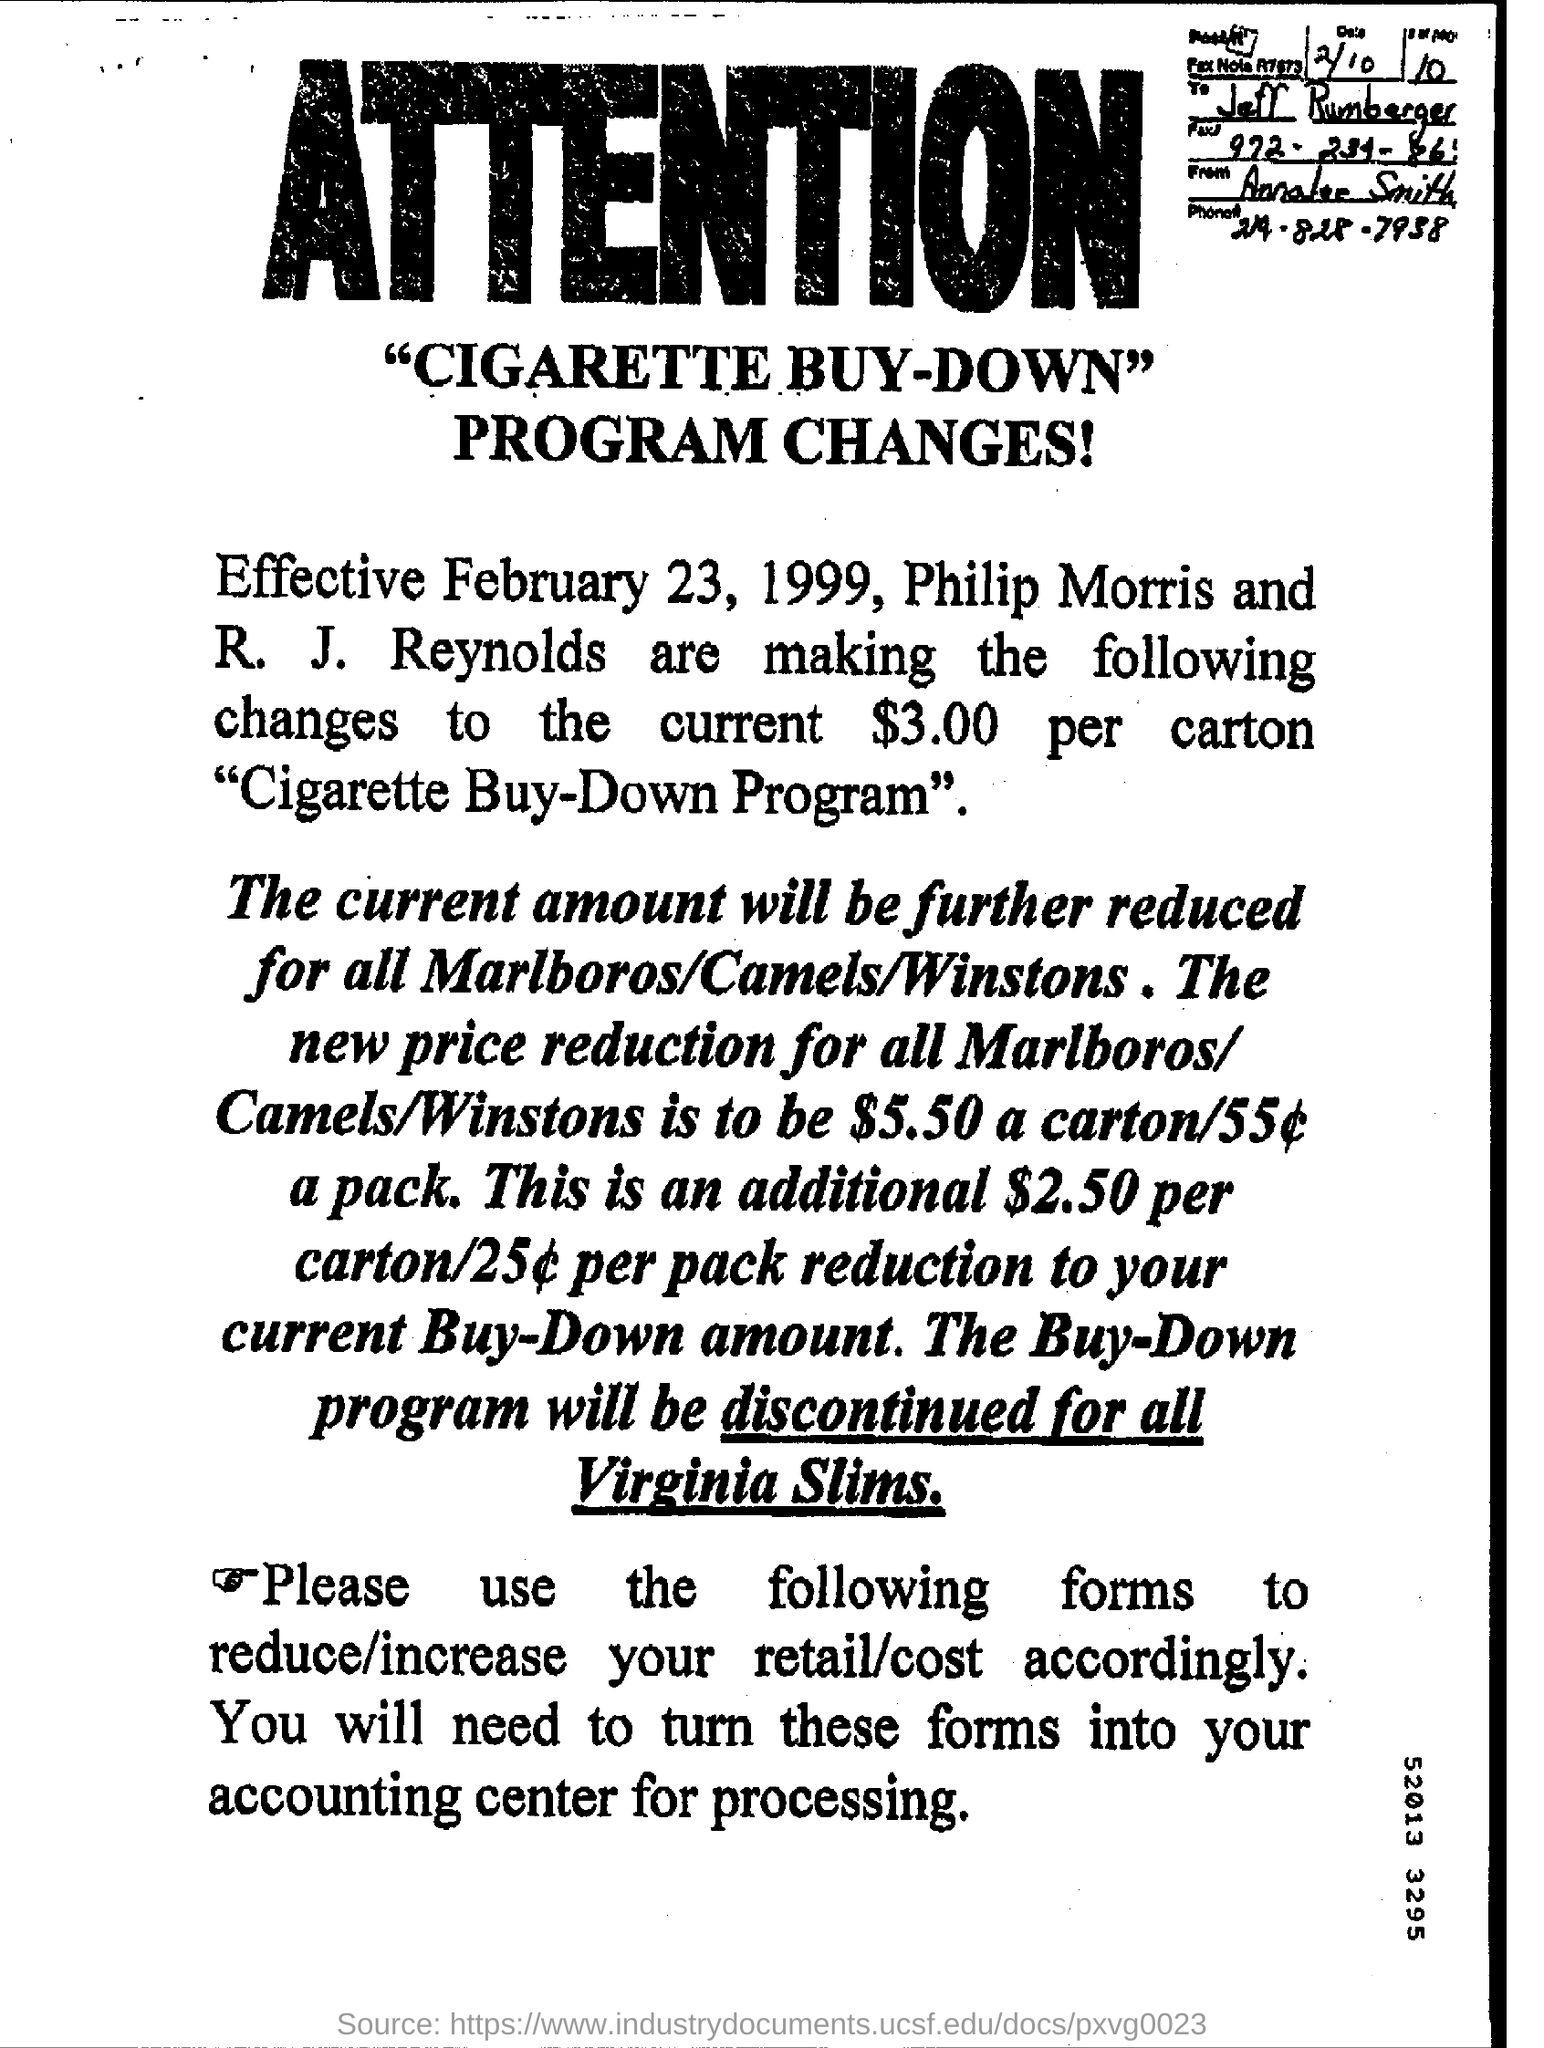Point out several critical features in this image. Effective immediately, the price of all Marlboros/Camels/Winstons has been reduced by $5.50 per carton, resulting in a per pack price of $55. The program change shall become effective from February 23, 1999. The phone number given is 219-828-7938. The current amount will be further reduced for the items of Marlboros/Camels/Winstons. The note is addressed to Jeff Rumberger. 